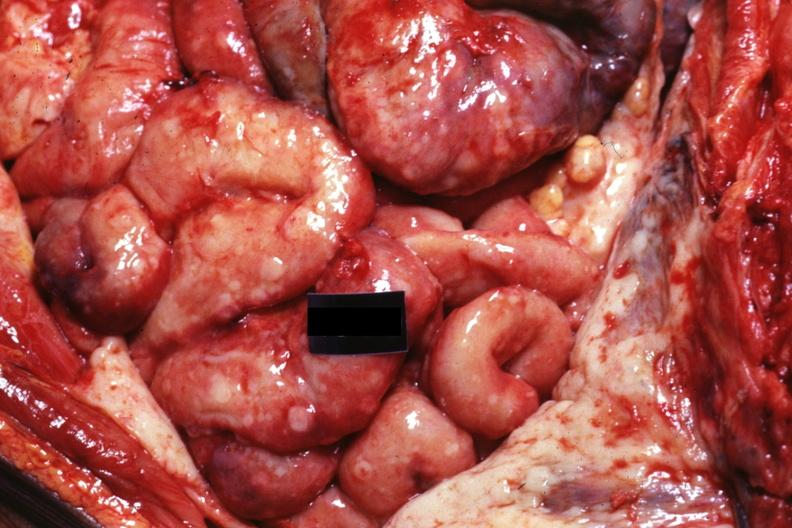s peritoneum present?
Answer the question using a single word or phrase. Yes 